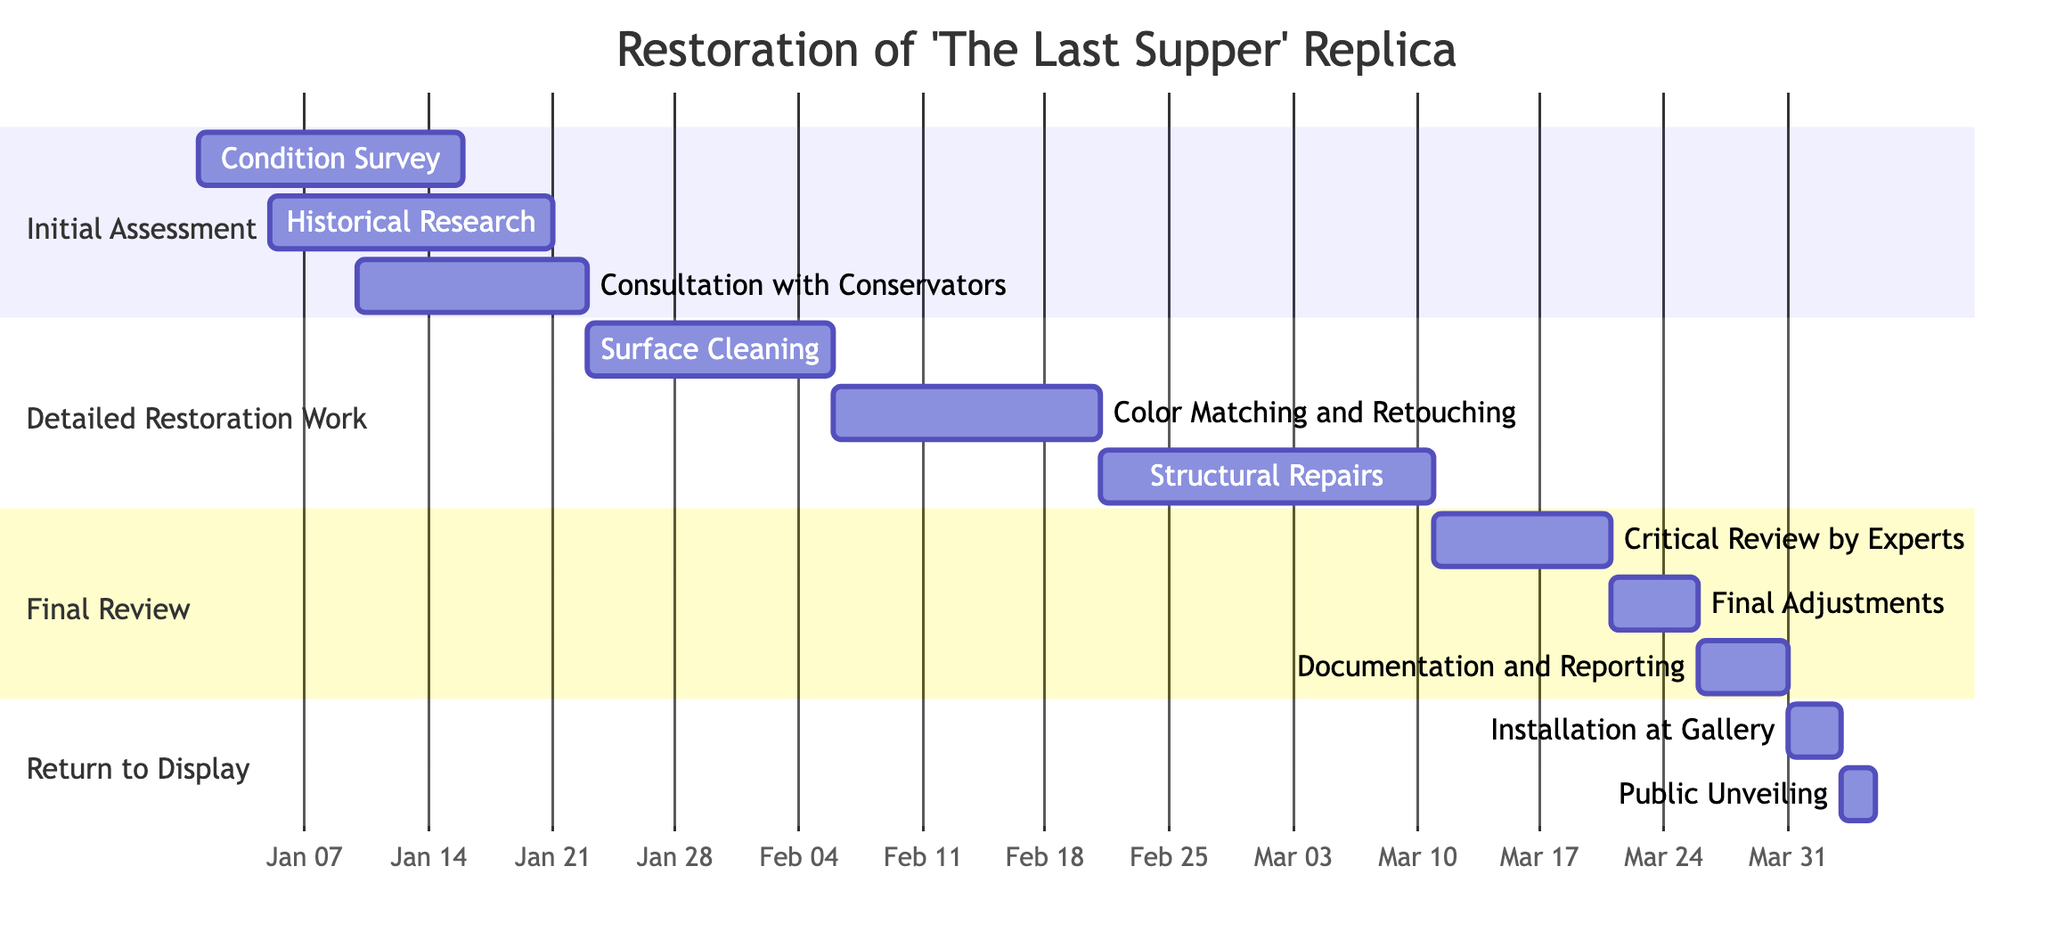What is the total duration of the Initial Assessment phase? The Initial Assessment phase comprises three tasks: Condition Survey (15 days), Historical Research (16 days), and Consultation with Conservators (13 days). The longest task, Historical Research, sets the duration, making it a total of 16 days.
Answer: 16 days Which task starts first in the Detailed Restoration Work phase? Within the Detailed Restoration Work phase, the tasks are listed in chronological order. Surface Cleaning starts on January 23, which is earlier than the others.
Answer: Surface Cleaning How many tasks are there in the Final Review phase? The Final Review phase has three listed tasks: Critical Review by Experts, Final Adjustments, and Documentation and Reporting. Counting them gives a total of three tasks.
Answer: 3 What is the start date of the Color Matching and Retouching task? Referring to the Detailed Restoration Work section, the Color Matching and Retouching task is scheduled to begin on February 6, 2024.
Answer: February 6, 2024 When does the Return to Display phase begin? The Return to Display phase has its first task, Installation at Gallery, starting on March 31, 2024. This is when this phase commences.
Answer: March 31, 2024 What is the last task in the project timeline? The last task listed in the entire timeline is the Public Unveiling, which is set to occur on April 4, 2024.
Answer: Public Unveiling Which phase contains the task "Documentation and Reporting"? Looking at the diagram, the task "Documentation and Reporting" is part of the Final Review phase, where it is the last task listed.
Answer: Final Review How many days are there between the end of Surface Cleaning and the start of Color Matching and Retouching? Surface Cleaning ends on February 5, and Color Matching and Retouching starts on February 6. There is just one day between the end of one task and the start of the next task.
Answer: 1 day What is the duration of the Structural Repairs task? The Structural Repairs task starts on February 21 and lasts until March 10. Calculating the days gives a total of 19 days for this task.
Answer: 19 days 